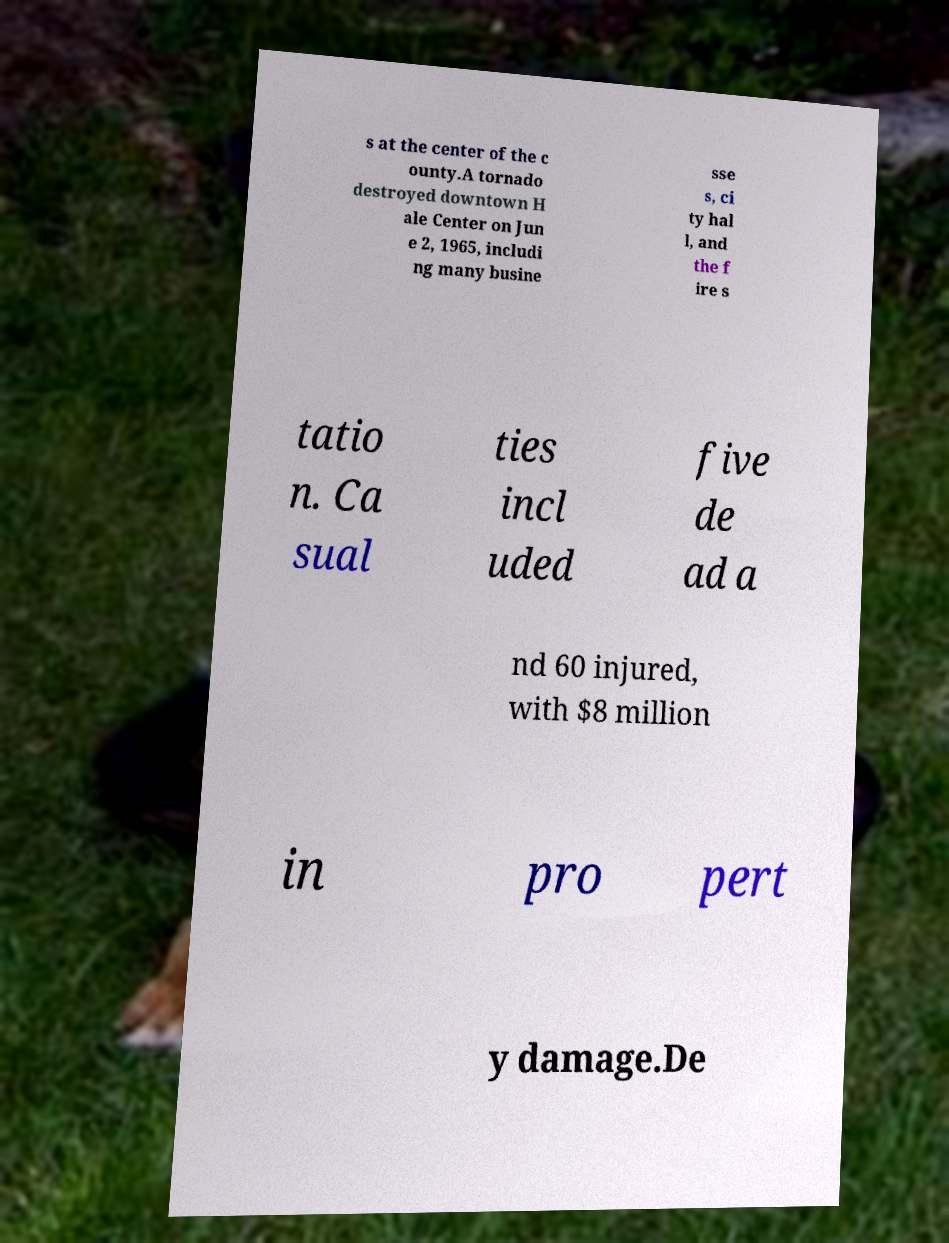Please identify and transcribe the text found in this image. s at the center of the c ounty.A tornado destroyed downtown H ale Center on Jun e 2, 1965, includi ng many busine sse s, ci ty hal l, and the f ire s tatio n. Ca sual ties incl uded five de ad a nd 60 injured, with $8 million in pro pert y damage.De 